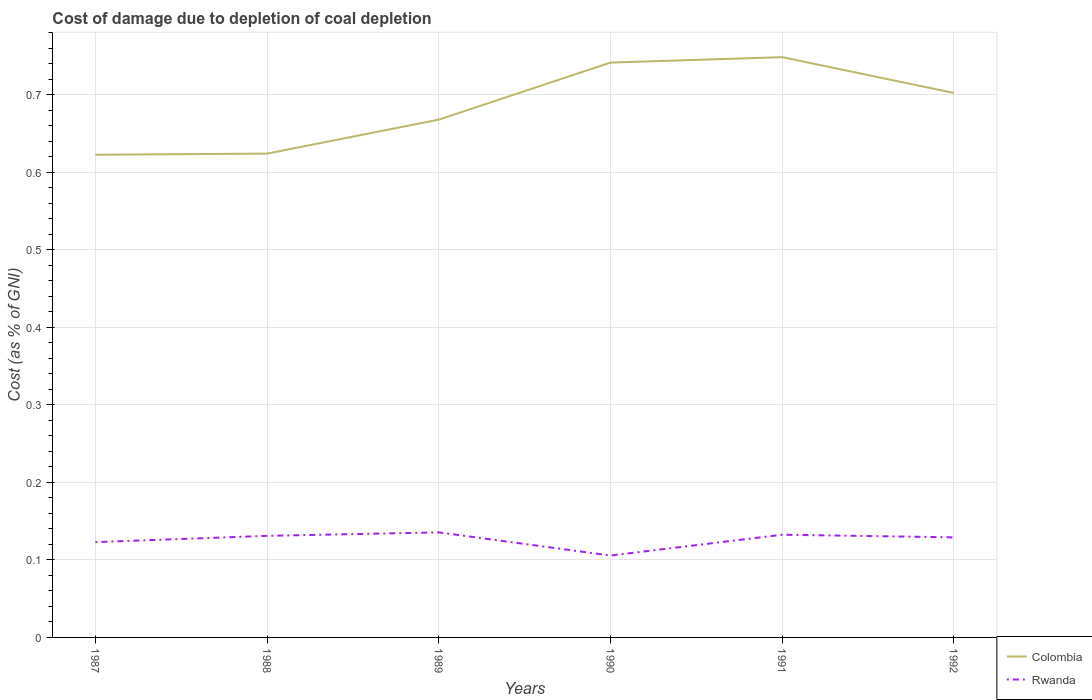Is the number of lines equal to the number of legend labels?
Give a very brief answer. Yes. Across all years, what is the maximum cost of damage caused due to coal depletion in Rwanda?
Your answer should be compact. 0.11. In which year was the cost of damage caused due to coal depletion in Rwanda maximum?
Keep it short and to the point. 1990. What is the total cost of damage caused due to coal depletion in Rwanda in the graph?
Your response must be concise. 0.03. What is the difference between the highest and the second highest cost of damage caused due to coal depletion in Rwanda?
Ensure brevity in your answer.  0.03. Is the cost of damage caused due to coal depletion in Rwanda strictly greater than the cost of damage caused due to coal depletion in Colombia over the years?
Provide a short and direct response. Yes. How many years are there in the graph?
Keep it short and to the point. 6. What is the difference between two consecutive major ticks on the Y-axis?
Make the answer very short. 0.1. How many legend labels are there?
Ensure brevity in your answer.  2. How are the legend labels stacked?
Provide a short and direct response. Vertical. What is the title of the graph?
Ensure brevity in your answer.  Cost of damage due to depletion of coal depletion. Does "Indonesia" appear as one of the legend labels in the graph?
Your answer should be very brief. No. What is the label or title of the Y-axis?
Offer a very short reply. Cost (as % of GNI). What is the Cost (as % of GNI) of Colombia in 1987?
Your answer should be very brief. 0.62. What is the Cost (as % of GNI) in Rwanda in 1987?
Your answer should be very brief. 0.12. What is the Cost (as % of GNI) of Colombia in 1988?
Ensure brevity in your answer.  0.62. What is the Cost (as % of GNI) in Rwanda in 1988?
Provide a succinct answer. 0.13. What is the Cost (as % of GNI) of Colombia in 1989?
Offer a terse response. 0.67. What is the Cost (as % of GNI) in Rwanda in 1989?
Ensure brevity in your answer.  0.14. What is the Cost (as % of GNI) of Colombia in 1990?
Keep it short and to the point. 0.74. What is the Cost (as % of GNI) in Rwanda in 1990?
Offer a very short reply. 0.11. What is the Cost (as % of GNI) in Colombia in 1991?
Provide a short and direct response. 0.75. What is the Cost (as % of GNI) of Rwanda in 1991?
Make the answer very short. 0.13. What is the Cost (as % of GNI) in Colombia in 1992?
Offer a very short reply. 0.7. What is the Cost (as % of GNI) in Rwanda in 1992?
Provide a succinct answer. 0.13. Across all years, what is the maximum Cost (as % of GNI) of Colombia?
Give a very brief answer. 0.75. Across all years, what is the maximum Cost (as % of GNI) of Rwanda?
Offer a very short reply. 0.14. Across all years, what is the minimum Cost (as % of GNI) in Colombia?
Your response must be concise. 0.62. Across all years, what is the minimum Cost (as % of GNI) of Rwanda?
Your answer should be compact. 0.11. What is the total Cost (as % of GNI) in Colombia in the graph?
Offer a very short reply. 4.11. What is the total Cost (as % of GNI) in Rwanda in the graph?
Keep it short and to the point. 0.76. What is the difference between the Cost (as % of GNI) of Colombia in 1987 and that in 1988?
Provide a short and direct response. -0. What is the difference between the Cost (as % of GNI) in Rwanda in 1987 and that in 1988?
Provide a short and direct response. -0.01. What is the difference between the Cost (as % of GNI) in Colombia in 1987 and that in 1989?
Your answer should be compact. -0.05. What is the difference between the Cost (as % of GNI) of Rwanda in 1987 and that in 1989?
Make the answer very short. -0.01. What is the difference between the Cost (as % of GNI) in Colombia in 1987 and that in 1990?
Offer a very short reply. -0.12. What is the difference between the Cost (as % of GNI) in Rwanda in 1987 and that in 1990?
Your answer should be very brief. 0.02. What is the difference between the Cost (as % of GNI) in Colombia in 1987 and that in 1991?
Your response must be concise. -0.13. What is the difference between the Cost (as % of GNI) in Rwanda in 1987 and that in 1991?
Your answer should be very brief. -0.01. What is the difference between the Cost (as % of GNI) in Colombia in 1987 and that in 1992?
Ensure brevity in your answer.  -0.08. What is the difference between the Cost (as % of GNI) in Rwanda in 1987 and that in 1992?
Provide a short and direct response. -0.01. What is the difference between the Cost (as % of GNI) of Colombia in 1988 and that in 1989?
Offer a terse response. -0.04. What is the difference between the Cost (as % of GNI) of Rwanda in 1988 and that in 1989?
Ensure brevity in your answer.  -0. What is the difference between the Cost (as % of GNI) of Colombia in 1988 and that in 1990?
Give a very brief answer. -0.12. What is the difference between the Cost (as % of GNI) of Rwanda in 1988 and that in 1990?
Offer a very short reply. 0.03. What is the difference between the Cost (as % of GNI) of Colombia in 1988 and that in 1991?
Offer a very short reply. -0.12. What is the difference between the Cost (as % of GNI) of Rwanda in 1988 and that in 1991?
Ensure brevity in your answer.  -0. What is the difference between the Cost (as % of GNI) in Colombia in 1988 and that in 1992?
Offer a very short reply. -0.08. What is the difference between the Cost (as % of GNI) of Rwanda in 1988 and that in 1992?
Make the answer very short. 0. What is the difference between the Cost (as % of GNI) of Colombia in 1989 and that in 1990?
Your answer should be very brief. -0.07. What is the difference between the Cost (as % of GNI) in Rwanda in 1989 and that in 1990?
Offer a very short reply. 0.03. What is the difference between the Cost (as % of GNI) in Colombia in 1989 and that in 1991?
Keep it short and to the point. -0.08. What is the difference between the Cost (as % of GNI) in Rwanda in 1989 and that in 1991?
Provide a succinct answer. 0. What is the difference between the Cost (as % of GNI) in Colombia in 1989 and that in 1992?
Provide a succinct answer. -0.03. What is the difference between the Cost (as % of GNI) in Rwanda in 1989 and that in 1992?
Provide a short and direct response. 0.01. What is the difference between the Cost (as % of GNI) of Colombia in 1990 and that in 1991?
Give a very brief answer. -0.01. What is the difference between the Cost (as % of GNI) of Rwanda in 1990 and that in 1991?
Give a very brief answer. -0.03. What is the difference between the Cost (as % of GNI) of Colombia in 1990 and that in 1992?
Offer a very short reply. 0.04. What is the difference between the Cost (as % of GNI) in Rwanda in 1990 and that in 1992?
Provide a succinct answer. -0.02. What is the difference between the Cost (as % of GNI) in Colombia in 1991 and that in 1992?
Offer a very short reply. 0.05. What is the difference between the Cost (as % of GNI) in Rwanda in 1991 and that in 1992?
Your answer should be compact. 0. What is the difference between the Cost (as % of GNI) in Colombia in 1987 and the Cost (as % of GNI) in Rwanda in 1988?
Offer a very short reply. 0.49. What is the difference between the Cost (as % of GNI) in Colombia in 1987 and the Cost (as % of GNI) in Rwanda in 1989?
Offer a very short reply. 0.49. What is the difference between the Cost (as % of GNI) in Colombia in 1987 and the Cost (as % of GNI) in Rwanda in 1990?
Provide a succinct answer. 0.52. What is the difference between the Cost (as % of GNI) of Colombia in 1987 and the Cost (as % of GNI) of Rwanda in 1991?
Keep it short and to the point. 0.49. What is the difference between the Cost (as % of GNI) of Colombia in 1987 and the Cost (as % of GNI) of Rwanda in 1992?
Your answer should be very brief. 0.49. What is the difference between the Cost (as % of GNI) of Colombia in 1988 and the Cost (as % of GNI) of Rwanda in 1989?
Keep it short and to the point. 0.49. What is the difference between the Cost (as % of GNI) of Colombia in 1988 and the Cost (as % of GNI) of Rwanda in 1990?
Your response must be concise. 0.52. What is the difference between the Cost (as % of GNI) of Colombia in 1988 and the Cost (as % of GNI) of Rwanda in 1991?
Give a very brief answer. 0.49. What is the difference between the Cost (as % of GNI) in Colombia in 1988 and the Cost (as % of GNI) in Rwanda in 1992?
Ensure brevity in your answer.  0.5. What is the difference between the Cost (as % of GNI) in Colombia in 1989 and the Cost (as % of GNI) in Rwanda in 1990?
Provide a succinct answer. 0.56. What is the difference between the Cost (as % of GNI) in Colombia in 1989 and the Cost (as % of GNI) in Rwanda in 1991?
Keep it short and to the point. 0.54. What is the difference between the Cost (as % of GNI) in Colombia in 1989 and the Cost (as % of GNI) in Rwanda in 1992?
Make the answer very short. 0.54. What is the difference between the Cost (as % of GNI) of Colombia in 1990 and the Cost (as % of GNI) of Rwanda in 1991?
Keep it short and to the point. 0.61. What is the difference between the Cost (as % of GNI) of Colombia in 1990 and the Cost (as % of GNI) of Rwanda in 1992?
Offer a terse response. 0.61. What is the difference between the Cost (as % of GNI) in Colombia in 1991 and the Cost (as % of GNI) in Rwanda in 1992?
Give a very brief answer. 0.62. What is the average Cost (as % of GNI) of Colombia per year?
Offer a terse response. 0.68. What is the average Cost (as % of GNI) of Rwanda per year?
Keep it short and to the point. 0.13. In the year 1987, what is the difference between the Cost (as % of GNI) of Colombia and Cost (as % of GNI) of Rwanda?
Provide a short and direct response. 0.5. In the year 1988, what is the difference between the Cost (as % of GNI) in Colombia and Cost (as % of GNI) in Rwanda?
Offer a very short reply. 0.49. In the year 1989, what is the difference between the Cost (as % of GNI) in Colombia and Cost (as % of GNI) in Rwanda?
Offer a terse response. 0.53. In the year 1990, what is the difference between the Cost (as % of GNI) in Colombia and Cost (as % of GNI) in Rwanda?
Your answer should be compact. 0.64. In the year 1991, what is the difference between the Cost (as % of GNI) of Colombia and Cost (as % of GNI) of Rwanda?
Provide a succinct answer. 0.62. In the year 1992, what is the difference between the Cost (as % of GNI) of Colombia and Cost (as % of GNI) of Rwanda?
Ensure brevity in your answer.  0.57. What is the ratio of the Cost (as % of GNI) in Rwanda in 1987 to that in 1988?
Offer a terse response. 0.94. What is the ratio of the Cost (as % of GNI) in Colombia in 1987 to that in 1989?
Make the answer very short. 0.93. What is the ratio of the Cost (as % of GNI) in Rwanda in 1987 to that in 1989?
Provide a succinct answer. 0.91. What is the ratio of the Cost (as % of GNI) in Colombia in 1987 to that in 1990?
Your answer should be compact. 0.84. What is the ratio of the Cost (as % of GNI) in Rwanda in 1987 to that in 1990?
Keep it short and to the point. 1.16. What is the ratio of the Cost (as % of GNI) of Colombia in 1987 to that in 1991?
Provide a short and direct response. 0.83. What is the ratio of the Cost (as % of GNI) of Rwanda in 1987 to that in 1991?
Provide a short and direct response. 0.93. What is the ratio of the Cost (as % of GNI) of Colombia in 1987 to that in 1992?
Give a very brief answer. 0.89. What is the ratio of the Cost (as % of GNI) in Rwanda in 1987 to that in 1992?
Your answer should be very brief. 0.95. What is the ratio of the Cost (as % of GNI) of Colombia in 1988 to that in 1989?
Ensure brevity in your answer.  0.93. What is the ratio of the Cost (as % of GNI) of Rwanda in 1988 to that in 1989?
Ensure brevity in your answer.  0.97. What is the ratio of the Cost (as % of GNI) in Colombia in 1988 to that in 1990?
Offer a very short reply. 0.84. What is the ratio of the Cost (as % of GNI) of Rwanda in 1988 to that in 1990?
Make the answer very short. 1.24. What is the ratio of the Cost (as % of GNI) in Colombia in 1988 to that in 1991?
Provide a succinct answer. 0.83. What is the ratio of the Cost (as % of GNI) of Colombia in 1988 to that in 1992?
Your answer should be very brief. 0.89. What is the ratio of the Cost (as % of GNI) of Colombia in 1989 to that in 1990?
Make the answer very short. 0.9. What is the ratio of the Cost (as % of GNI) of Rwanda in 1989 to that in 1990?
Your response must be concise. 1.28. What is the ratio of the Cost (as % of GNI) of Colombia in 1989 to that in 1991?
Ensure brevity in your answer.  0.89. What is the ratio of the Cost (as % of GNI) of Rwanda in 1989 to that in 1991?
Offer a very short reply. 1.02. What is the ratio of the Cost (as % of GNI) in Colombia in 1989 to that in 1992?
Offer a terse response. 0.95. What is the ratio of the Cost (as % of GNI) of Rwanda in 1989 to that in 1992?
Give a very brief answer. 1.05. What is the ratio of the Cost (as % of GNI) in Colombia in 1990 to that in 1991?
Your answer should be compact. 0.99. What is the ratio of the Cost (as % of GNI) of Rwanda in 1990 to that in 1991?
Give a very brief answer. 0.8. What is the ratio of the Cost (as % of GNI) in Colombia in 1990 to that in 1992?
Provide a short and direct response. 1.06. What is the ratio of the Cost (as % of GNI) in Rwanda in 1990 to that in 1992?
Offer a terse response. 0.82. What is the ratio of the Cost (as % of GNI) of Colombia in 1991 to that in 1992?
Provide a short and direct response. 1.07. What is the ratio of the Cost (as % of GNI) of Rwanda in 1991 to that in 1992?
Ensure brevity in your answer.  1.03. What is the difference between the highest and the second highest Cost (as % of GNI) in Colombia?
Make the answer very short. 0.01. What is the difference between the highest and the second highest Cost (as % of GNI) of Rwanda?
Ensure brevity in your answer.  0. What is the difference between the highest and the lowest Cost (as % of GNI) of Colombia?
Offer a terse response. 0.13. What is the difference between the highest and the lowest Cost (as % of GNI) in Rwanda?
Offer a very short reply. 0.03. 